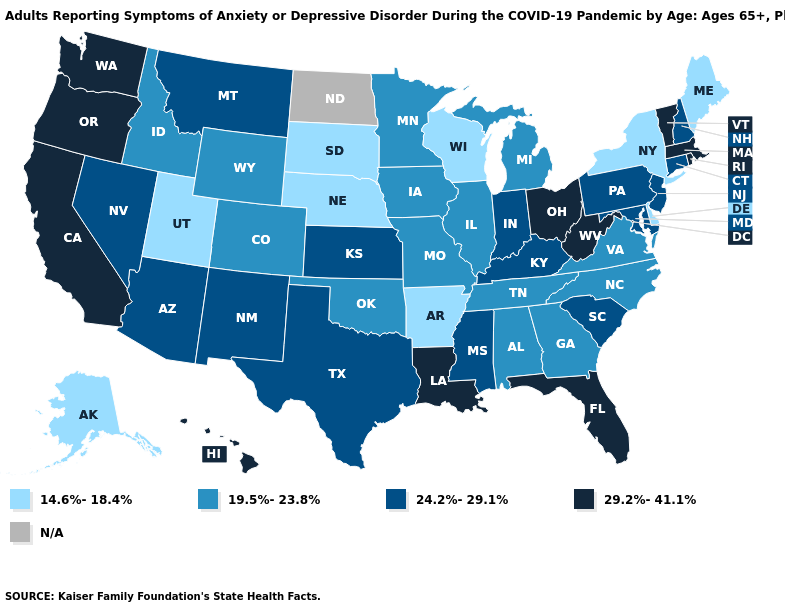Is the legend a continuous bar?
Keep it brief. No. What is the value of South Dakota?
Write a very short answer. 14.6%-18.4%. What is the value of Alabama?
Short answer required. 19.5%-23.8%. Among the states that border North Carolina , which have the lowest value?
Short answer required. Georgia, Tennessee, Virginia. Which states have the lowest value in the MidWest?
Be succinct. Nebraska, South Dakota, Wisconsin. Name the states that have a value in the range 14.6%-18.4%?
Quick response, please. Alaska, Arkansas, Delaware, Maine, Nebraska, New York, South Dakota, Utah, Wisconsin. Among the states that border Kansas , which have the highest value?
Be succinct. Colorado, Missouri, Oklahoma. What is the value of Tennessee?
Answer briefly. 19.5%-23.8%. Which states have the highest value in the USA?
Quick response, please. California, Florida, Hawaii, Louisiana, Massachusetts, Ohio, Oregon, Rhode Island, Vermont, Washington, West Virginia. What is the highest value in the West ?
Be succinct. 29.2%-41.1%. What is the value of Virginia?
Quick response, please. 19.5%-23.8%. Does Arkansas have the lowest value in the South?
Be succinct. Yes. Which states have the lowest value in the USA?
Short answer required. Alaska, Arkansas, Delaware, Maine, Nebraska, New York, South Dakota, Utah, Wisconsin. What is the highest value in the USA?
Quick response, please. 29.2%-41.1%. What is the value of South Dakota?
Be succinct. 14.6%-18.4%. 